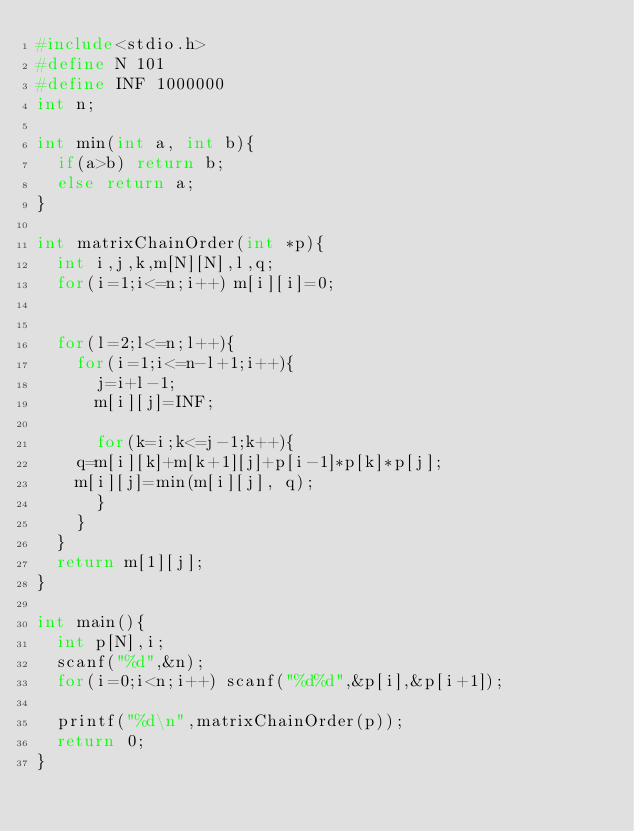<code> <loc_0><loc_0><loc_500><loc_500><_C_>#include<stdio.h>
#define N 101
#define INF 1000000
int n;

int min(int a, int b){
  if(a>b) return b;
  else return a;
}

int matrixChainOrder(int *p){
  int i,j,k,m[N][N],l,q;
  for(i=1;i<=n;i++) m[i][i]=0;
 
  
  for(l=2;l<=n;l++){
    for(i=1;i<=n-l+1;i++){
      j=i+l-1;
      m[i][j]=INF;
      
      for(k=i;k<=j-1;k++){
	q=m[i][k]+m[k+1][j]+p[i-1]*p[k]*p[j];
	m[i][j]=min(m[i][j], q);
      }
    }
  }
  return m[1][j];
}

int main(){
  int p[N],i;
  scanf("%d",&n);
  for(i=0;i<n;i++) scanf("%d%d",&p[i],&p[i+1]);

  printf("%d\n",matrixChainOrder(p));
  return 0;
}

</code> 